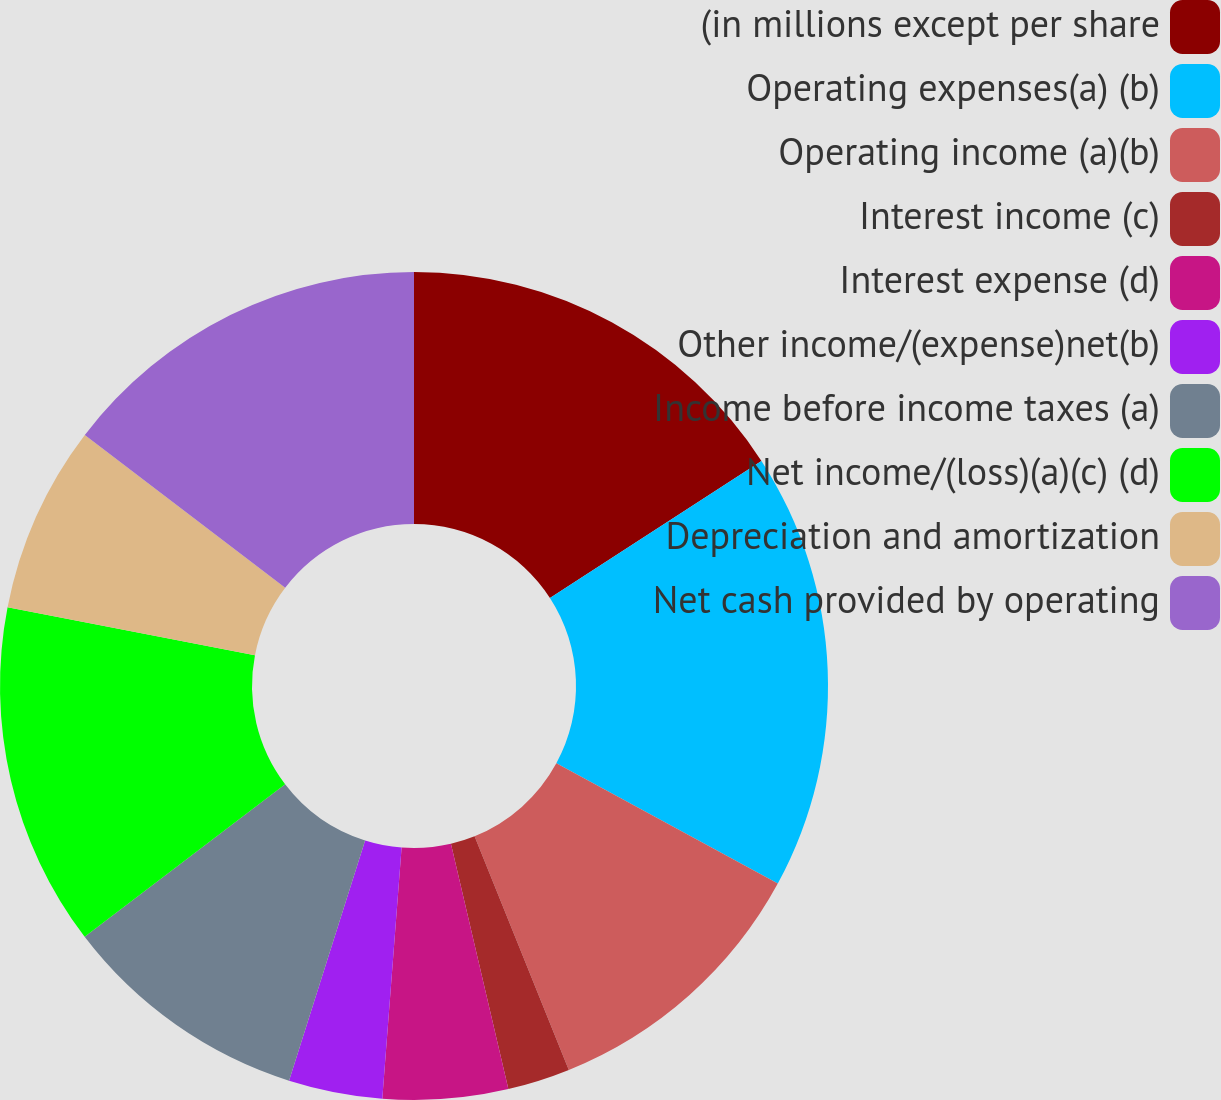Convert chart. <chart><loc_0><loc_0><loc_500><loc_500><pie_chart><fcel>(in millions except per share<fcel>Operating expenses(a) (b)<fcel>Operating income (a)(b)<fcel>Interest income (c)<fcel>Interest expense (d)<fcel>Other income/(expense)net(b)<fcel>Income before income taxes (a)<fcel>Net income/(loss)(a)(c) (d)<fcel>Depreciation and amortization<fcel>Net cash provided by operating<nl><fcel>15.85%<fcel>17.07%<fcel>10.98%<fcel>2.44%<fcel>4.88%<fcel>3.66%<fcel>9.76%<fcel>13.41%<fcel>7.32%<fcel>14.63%<nl></chart> 